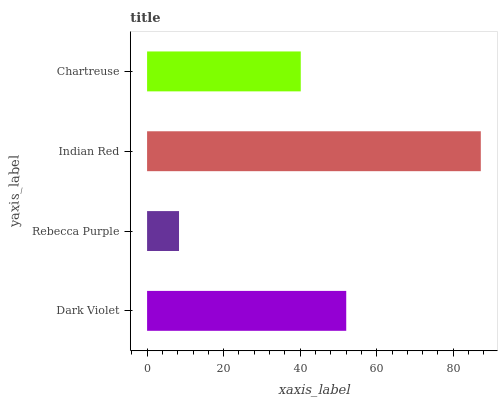Is Rebecca Purple the minimum?
Answer yes or no. Yes. Is Indian Red the maximum?
Answer yes or no. Yes. Is Indian Red the minimum?
Answer yes or no. No. Is Rebecca Purple the maximum?
Answer yes or no. No. Is Indian Red greater than Rebecca Purple?
Answer yes or no. Yes. Is Rebecca Purple less than Indian Red?
Answer yes or no. Yes. Is Rebecca Purple greater than Indian Red?
Answer yes or no. No. Is Indian Red less than Rebecca Purple?
Answer yes or no. No. Is Dark Violet the high median?
Answer yes or no. Yes. Is Chartreuse the low median?
Answer yes or no. Yes. Is Indian Red the high median?
Answer yes or no. No. Is Dark Violet the low median?
Answer yes or no. No. 